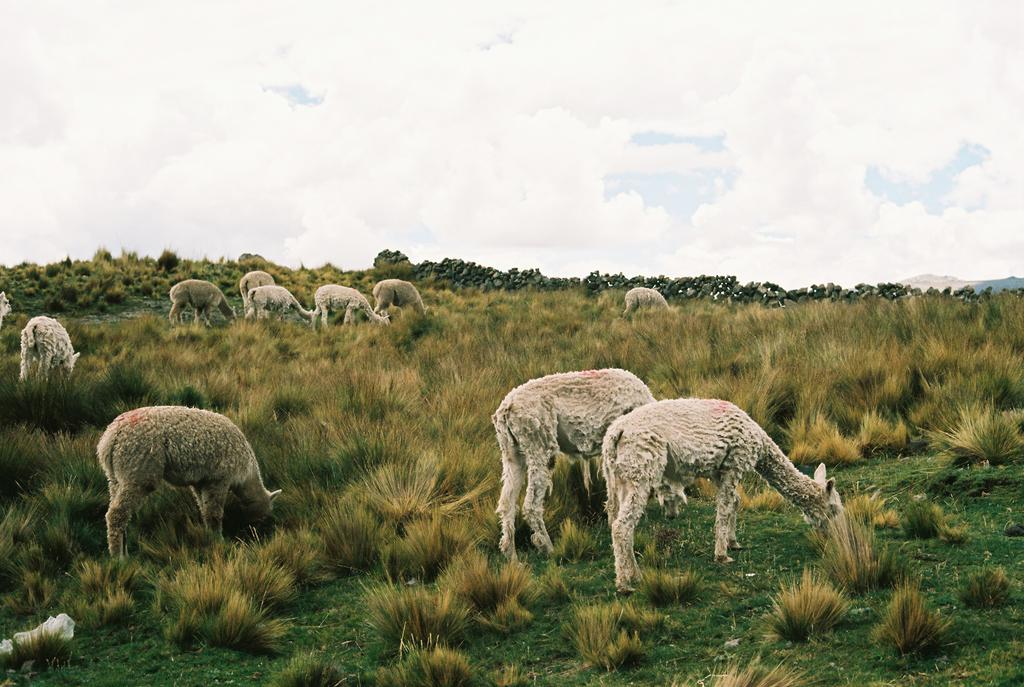What type of animals can be seen in the image? There are sheep in the image. What other living organisms are present in the image? There are plants in the image. What type of ground cover is visible in the image? There is grass on the ground in the image. What is the condition of the sky in the image? The sky is cloudy in the image. What type of grape is being used to express disgust in the image? There is no grape present in the image, nor is there any expression of disgust. 